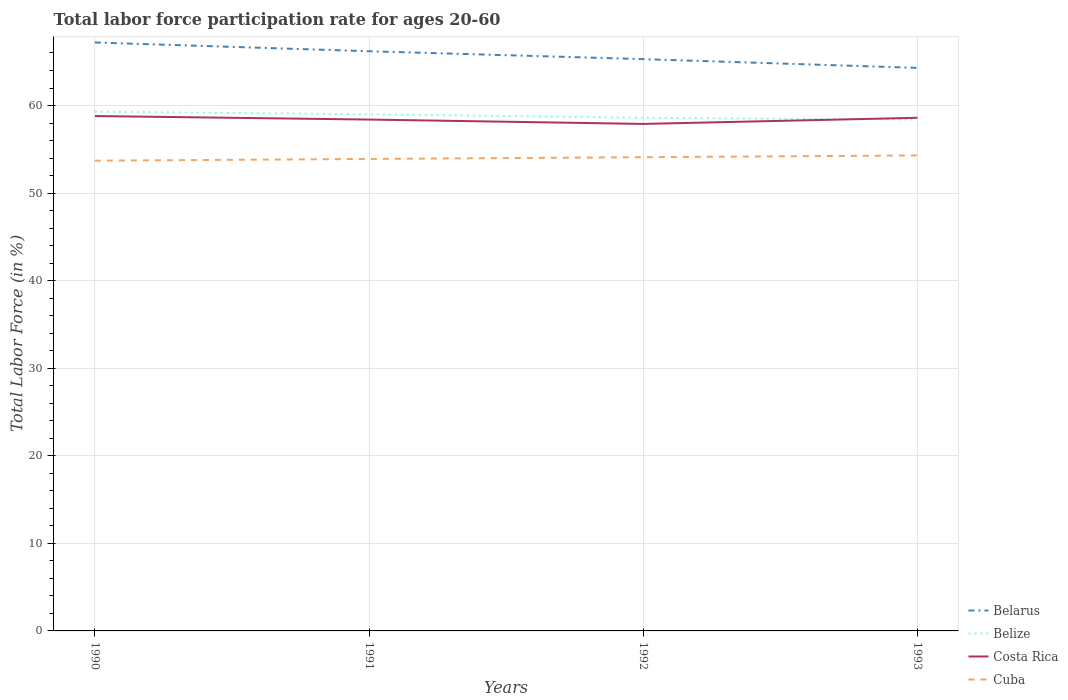Does the line corresponding to Costa Rica intersect with the line corresponding to Belize?
Provide a succinct answer. Yes. Is the number of lines equal to the number of legend labels?
Provide a short and direct response. Yes. Across all years, what is the maximum labor force participation rate in Belize?
Your answer should be very brief. 58.4. What is the total labor force participation rate in Belize in the graph?
Keep it short and to the point. 0.9. What is the difference between the highest and the second highest labor force participation rate in Costa Rica?
Provide a succinct answer. 0.9. What is the difference between the highest and the lowest labor force participation rate in Costa Rica?
Ensure brevity in your answer.  2. Are the values on the major ticks of Y-axis written in scientific E-notation?
Offer a very short reply. No. Does the graph contain any zero values?
Keep it short and to the point. No. Does the graph contain grids?
Give a very brief answer. Yes. Where does the legend appear in the graph?
Offer a very short reply. Bottom right. How many legend labels are there?
Your answer should be very brief. 4. How are the legend labels stacked?
Provide a short and direct response. Vertical. What is the title of the graph?
Your response must be concise. Total labor force participation rate for ages 20-60. Does "Armenia" appear as one of the legend labels in the graph?
Keep it short and to the point. No. What is the label or title of the X-axis?
Offer a terse response. Years. What is the label or title of the Y-axis?
Make the answer very short. Total Labor Force (in %). What is the Total Labor Force (in %) in Belarus in 1990?
Your answer should be very brief. 67.2. What is the Total Labor Force (in %) of Belize in 1990?
Keep it short and to the point. 59.3. What is the Total Labor Force (in %) of Costa Rica in 1990?
Keep it short and to the point. 58.8. What is the Total Labor Force (in %) of Cuba in 1990?
Provide a short and direct response. 53.7. What is the Total Labor Force (in %) in Belarus in 1991?
Your answer should be compact. 66.2. What is the Total Labor Force (in %) of Belize in 1991?
Your answer should be compact. 59. What is the Total Labor Force (in %) in Costa Rica in 1991?
Offer a very short reply. 58.4. What is the Total Labor Force (in %) in Cuba in 1991?
Offer a terse response. 53.9. What is the Total Labor Force (in %) of Belarus in 1992?
Offer a terse response. 65.3. What is the Total Labor Force (in %) of Belize in 1992?
Your answer should be compact. 58.6. What is the Total Labor Force (in %) of Costa Rica in 1992?
Make the answer very short. 57.9. What is the Total Labor Force (in %) in Cuba in 1992?
Keep it short and to the point. 54.1. What is the Total Labor Force (in %) in Belarus in 1993?
Provide a short and direct response. 64.3. What is the Total Labor Force (in %) in Belize in 1993?
Keep it short and to the point. 58.4. What is the Total Labor Force (in %) in Costa Rica in 1993?
Provide a succinct answer. 58.6. What is the Total Labor Force (in %) of Cuba in 1993?
Keep it short and to the point. 54.3. Across all years, what is the maximum Total Labor Force (in %) of Belarus?
Offer a very short reply. 67.2. Across all years, what is the maximum Total Labor Force (in %) of Belize?
Make the answer very short. 59.3. Across all years, what is the maximum Total Labor Force (in %) in Costa Rica?
Keep it short and to the point. 58.8. Across all years, what is the maximum Total Labor Force (in %) of Cuba?
Make the answer very short. 54.3. Across all years, what is the minimum Total Labor Force (in %) in Belarus?
Offer a terse response. 64.3. Across all years, what is the minimum Total Labor Force (in %) in Belize?
Ensure brevity in your answer.  58.4. Across all years, what is the minimum Total Labor Force (in %) of Costa Rica?
Ensure brevity in your answer.  57.9. Across all years, what is the minimum Total Labor Force (in %) in Cuba?
Offer a very short reply. 53.7. What is the total Total Labor Force (in %) of Belarus in the graph?
Your response must be concise. 263. What is the total Total Labor Force (in %) in Belize in the graph?
Give a very brief answer. 235.3. What is the total Total Labor Force (in %) in Costa Rica in the graph?
Offer a very short reply. 233.7. What is the total Total Labor Force (in %) in Cuba in the graph?
Make the answer very short. 216. What is the difference between the Total Labor Force (in %) in Belarus in 1990 and that in 1991?
Keep it short and to the point. 1. What is the difference between the Total Labor Force (in %) in Belize in 1990 and that in 1991?
Make the answer very short. 0.3. What is the difference between the Total Labor Force (in %) in Cuba in 1990 and that in 1991?
Give a very brief answer. -0.2. What is the difference between the Total Labor Force (in %) of Belize in 1990 and that in 1992?
Offer a very short reply. 0.7. What is the difference between the Total Labor Force (in %) of Costa Rica in 1990 and that in 1992?
Your response must be concise. 0.9. What is the difference between the Total Labor Force (in %) of Cuba in 1990 and that in 1992?
Your response must be concise. -0.4. What is the difference between the Total Labor Force (in %) of Belarus in 1990 and that in 1993?
Your answer should be compact. 2.9. What is the difference between the Total Labor Force (in %) in Cuba in 1990 and that in 1993?
Ensure brevity in your answer.  -0.6. What is the difference between the Total Labor Force (in %) in Belarus in 1991 and that in 1992?
Make the answer very short. 0.9. What is the difference between the Total Labor Force (in %) of Belarus in 1991 and that in 1993?
Your response must be concise. 1.9. What is the difference between the Total Labor Force (in %) of Costa Rica in 1991 and that in 1993?
Give a very brief answer. -0.2. What is the difference between the Total Labor Force (in %) in Cuba in 1991 and that in 1993?
Provide a succinct answer. -0.4. What is the difference between the Total Labor Force (in %) in Belarus in 1992 and that in 1993?
Offer a very short reply. 1. What is the difference between the Total Labor Force (in %) of Belize in 1992 and that in 1993?
Provide a short and direct response. 0.2. What is the difference between the Total Labor Force (in %) of Costa Rica in 1992 and that in 1993?
Ensure brevity in your answer.  -0.7. What is the difference between the Total Labor Force (in %) of Cuba in 1992 and that in 1993?
Provide a short and direct response. -0.2. What is the difference between the Total Labor Force (in %) of Belarus in 1990 and the Total Labor Force (in %) of Costa Rica in 1991?
Your answer should be compact. 8.8. What is the difference between the Total Labor Force (in %) in Belarus in 1990 and the Total Labor Force (in %) in Cuba in 1991?
Ensure brevity in your answer.  13.3. What is the difference between the Total Labor Force (in %) of Belize in 1990 and the Total Labor Force (in %) of Costa Rica in 1991?
Your answer should be very brief. 0.9. What is the difference between the Total Labor Force (in %) of Belarus in 1990 and the Total Labor Force (in %) of Cuba in 1992?
Keep it short and to the point. 13.1. What is the difference between the Total Labor Force (in %) in Belize in 1990 and the Total Labor Force (in %) in Cuba in 1992?
Your answer should be compact. 5.2. What is the difference between the Total Labor Force (in %) of Belarus in 1990 and the Total Labor Force (in %) of Cuba in 1993?
Your answer should be very brief. 12.9. What is the difference between the Total Labor Force (in %) in Belize in 1990 and the Total Labor Force (in %) in Costa Rica in 1993?
Ensure brevity in your answer.  0.7. What is the difference between the Total Labor Force (in %) in Belize in 1990 and the Total Labor Force (in %) in Cuba in 1993?
Give a very brief answer. 5. What is the difference between the Total Labor Force (in %) in Costa Rica in 1990 and the Total Labor Force (in %) in Cuba in 1993?
Offer a terse response. 4.5. What is the difference between the Total Labor Force (in %) of Belarus in 1991 and the Total Labor Force (in %) of Costa Rica in 1992?
Your answer should be compact. 8.3. What is the difference between the Total Labor Force (in %) in Belarus in 1991 and the Total Labor Force (in %) in Cuba in 1992?
Offer a very short reply. 12.1. What is the difference between the Total Labor Force (in %) of Belarus in 1991 and the Total Labor Force (in %) of Belize in 1993?
Your response must be concise. 7.8. What is the difference between the Total Labor Force (in %) of Belize in 1991 and the Total Labor Force (in %) of Cuba in 1993?
Keep it short and to the point. 4.7. What is the difference between the Total Labor Force (in %) in Belarus in 1992 and the Total Labor Force (in %) in Cuba in 1993?
Ensure brevity in your answer.  11. What is the difference between the Total Labor Force (in %) in Belize in 1992 and the Total Labor Force (in %) in Costa Rica in 1993?
Offer a terse response. 0. What is the difference between the Total Labor Force (in %) in Belize in 1992 and the Total Labor Force (in %) in Cuba in 1993?
Provide a succinct answer. 4.3. What is the average Total Labor Force (in %) in Belarus per year?
Offer a terse response. 65.75. What is the average Total Labor Force (in %) in Belize per year?
Make the answer very short. 58.83. What is the average Total Labor Force (in %) in Costa Rica per year?
Your answer should be very brief. 58.42. What is the average Total Labor Force (in %) in Cuba per year?
Your answer should be very brief. 54. In the year 1990, what is the difference between the Total Labor Force (in %) of Belize and Total Labor Force (in %) of Costa Rica?
Your answer should be very brief. 0.5. In the year 1991, what is the difference between the Total Labor Force (in %) in Belarus and Total Labor Force (in %) in Belize?
Give a very brief answer. 7.2. In the year 1991, what is the difference between the Total Labor Force (in %) in Belize and Total Labor Force (in %) in Costa Rica?
Offer a terse response. 0.6. In the year 1991, what is the difference between the Total Labor Force (in %) in Belize and Total Labor Force (in %) in Cuba?
Provide a short and direct response. 5.1. In the year 1992, what is the difference between the Total Labor Force (in %) of Belize and Total Labor Force (in %) of Costa Rica?
Your answer should be very brief. 0.7. In the year 1992, what is the difference between the Total Labor Force (in %) of Belize and Total Labor Force (in %) of Cuba?
Provide a succinct answer. 4.5. In the year 1993, what is the difference between the Total Labor Force (in %) in Belarus and Total Labor Force (in %) in Belize?
Give a very brief answer. 5.9. In the year 1993, what is the difference between the Total Labor Force (in %) of Belarus and Total Labor Force (in %) of Costa Rica?
Provide a succinct answer. 5.7. In the year 1993, what is the difference between the Total Labor Force (in %) in Belarus and Total Labor Force (in %) in Cuba?
Your answer should be compact. 10. In the year 1993, what is the difference between the Total Labor Force (in %) of Belize and Total Labor Force (in %) of Costa Rica?
Keep it short and to the point. -0.2. What is the ratio of the Total Labor Force (in %) in Belarus in 1990 to that in 1991?
Provide a succinct answer. 1.02. What is the ratio of the Total Labor Force (in %) in Costa Rica in 1990 to that in 1991?
Ensure brevity in your answer.  1.01. What is the ratio of the Total Labor Force (in %) of Belarus in 1990 to that in 1992?
Provide a short and direct response. 1.03. What is the ratio of the Total Labor Force (in %) in Belize in 1990 to that in 1992?
Give a very brief answer. 1.01. What is the ratio of the Total Labor Force (in %) of Costa Rica in 1990 to that in 1992?
Ensure brevity in your answer.  1.02. What is the ratio of the Total Labor Force (in %) of Belarus in 1990 to that in 1993?
Ensure brevity in your answer.  1.05. What is the ratio of the Total Labor Force (in %) of Belize in 1990 to that in 1993?
Your answer should be compact. 1.02. What is the ratio of the Total Labor Force (in %) in Belarus in 1991 to that in 1992?
Keep it short and to the point. 1.01. What is the ratio of the Total Labor Force (in %) of Belize in 1991 to that in 1992?
Your answer should be very brief. 1.01. What is the ratio of the Total Labor Force (in %) of Costa Rica in 1991 to that in 1992?
Make the answer very short. 1.01. What is the ratio of the Total Labor Force (in %) of Belarus in 1991 to that in 1993?
Your answer should be compact. 1.03. What is the ratio of the Total Labor Force (in %) in Belize in 1991 to that in 1993?
Offer a very short reply. 1.01. What is the ratio of the Total Labor Force (in %) of Costa Rica in 1991 to that in 1993?
Provide a succinct answer. 1. What is the ratio of the Total Labor Force (in %) of Cuba in 1991 to that in 1993?
Your answer should be very brief. 0.99. What is the ratio of the Total Labor Force (in %) in Belarus in 1992 to that in 1993?
Keep it short and to the point. 1.02. What is the ratio of the Total Labor Force (in %) of Belize in 1992 to that in 1993?
Provide a short and direct response. 1. What is the ratio of the Total Labor Force (in %) in Costa Rica in 1992 to that in 1993?
Your answer should be very brief. 0.99. What is the ratio of the Total Labor Force (in %) of Cuba in 1992 to that in 1993?
Provide a short and direct response. 1. What is the difference between the highest and the second highest Total Labor Force (in %) in Belize?
Keep it short and to the point. 0.3. What is the difference between the highest and the lowest Total Labor Force (in %) in Belarus?
Your answer should be very brief. 2.9. What is the difference between the highest and the lowest Total Labor Force (in %) in Costa Rica?
Offer a terse response. 0.9. What is the difference between the highest and the lowest Total Labor Force (in %) of Cuba?
Your answer should be very brief. 0.6. 